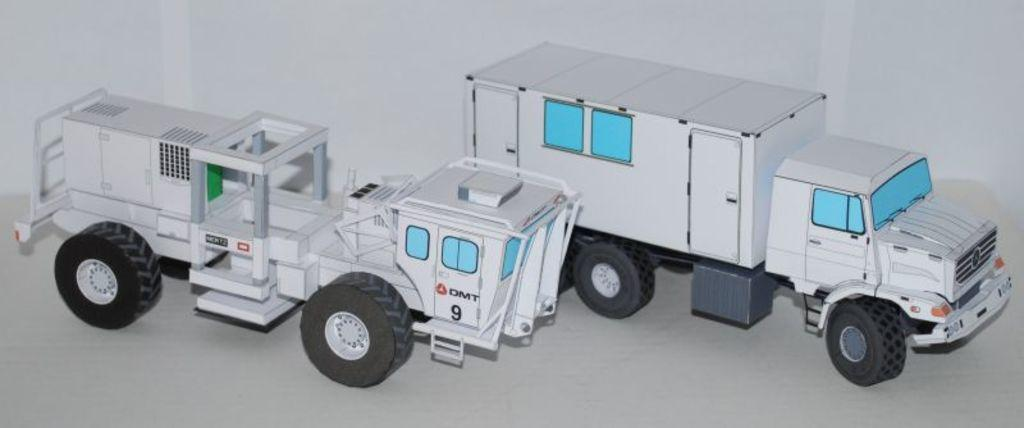What type of objects are present in the image? There are two toy vehicles in the image. Can you describe the colors of the toy vehicles? The toy vehicles are white, blue, black, and green in color. What is the surface on which the toy vehicles are placed? The toy vehicles are on a white colored surface. What color is the background of the image? The background of the image is white. Are there any pets visible in the image? There are no pets present in the image. Is there a campfire in the background of the image? There is no campfire or any indication of a camping scene in the image. 